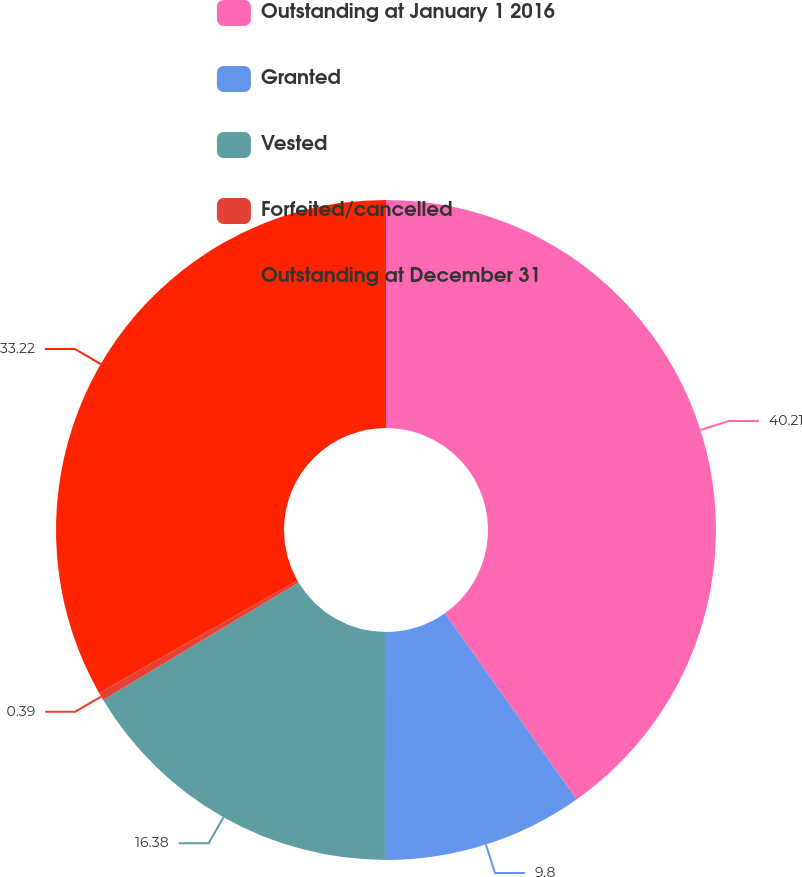Convert chart. <chart><loc_0><loc_0><loc_500><loc_500><pie_chart><fcel>Outstanding at January 1 2016<fcel>Granted<fcel>Vested<fcel>Forfeited/cancelled<fcel>Outstanding at December 31<nl><fcel>40.2%<fcel>9.8%<fcel>16.38%<fcel>0.39%<fcel>33.22%<nl></chart> 